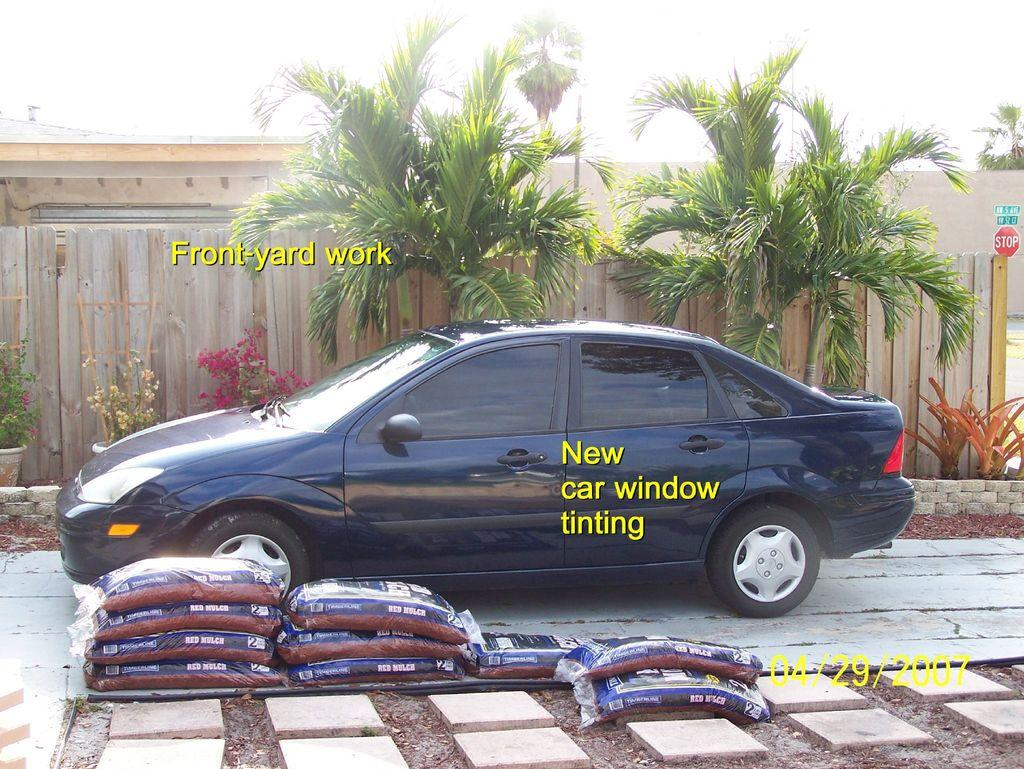<image>
Present a compact description of the photo's key features. A dark blue car that has just had its windows tinted. 